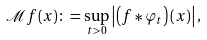Convert formula to latex. <formula><loc_0><loc_0><loc_500><loc_500>\mathcal { M } f ( x ) \colon = \sup _ { t > 0 } \left | \left ( f \ast \varphi _ { t } \right ) ( x ) \right | ,</formula> 